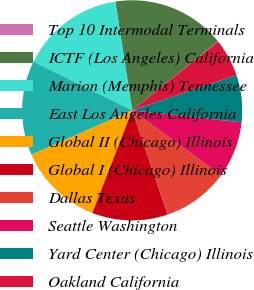<chart> <loc_0><loc_0><loc_500><loc_500><pie_chart><fcel>Top 10 Intermodal Terminals<fcel>ICTF (Los Angeles) California<fcel>Marion (Memphis) Tennessee<fcel>East Los Angeles California<fcel>Global II (Chicago) Illinois<fcel>Global I (Chicago) Illinois<fcel>Dallas Texas<fcel>Seattle Washington<fcel>Yard Center (Chicago) Illinois<fcel>Oakland California<nl><fcel>0.04%<fcel>16.67%<fcel>15.28%<fcel>13.89%<fcel>12.5%<fcel>11.11%<fcel>9.72%<fcel>8.32%<fcel>6.93%<fcel>5.54%<nl></chart> 